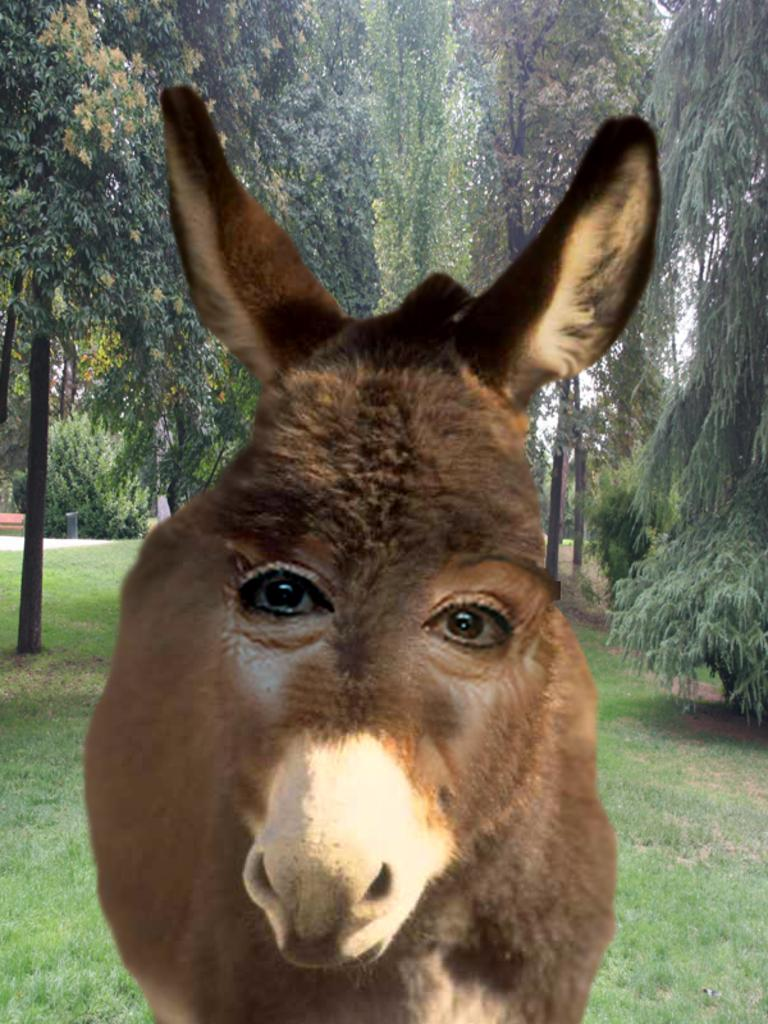What type of animal can be seen in the image? There is a brown animal in the image. What is the ground covered with in the image? There is grass on the ground in the image. What can be seen in the distance in the image? There are trees in the background of the image. Reasoning: Let's think step by identifying the main subjects and objects in the image based on the provided facts. We then formulate questions that focus on the location and characteristics of these subjects and objects, ensuring that each question can be answered definitively with the information given. We avoid yes/no questions and ensure that the language is simple and clear. Absurd Question/Answer: What type of bun is being used to feed the animal in the image? There is no bun present in the image, and the animal is not being fed. Is the animal stuck in quicksand in the image? No, the animal is not in quicksand; it is on grass. What type of paste is being used to create the trees in the background of the image? There is no paste present in the image, and the trees are real. 